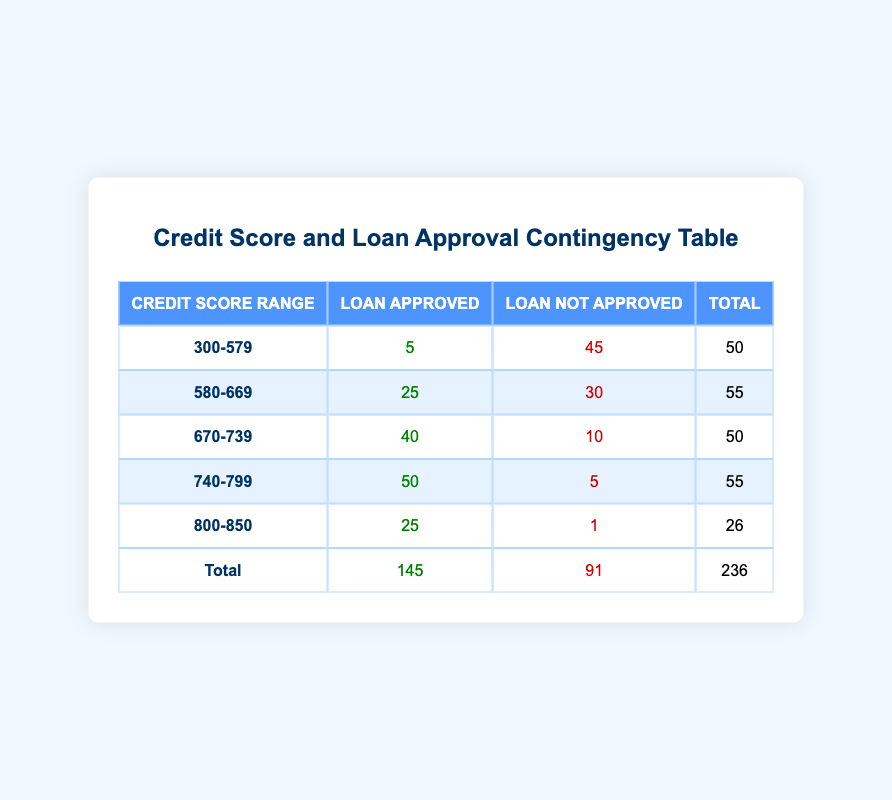What is the total number of loans approved for the credit score range 670-739? Looking at the table, the number of loans approved for the credit score range 670-739 is 40.
Answer: 40 What is the total number of loans not approved across all credit score ranges? Summing the values in the "Loan Not Approved" column gives: 45 + 30 + 10 + 5 + 1 = 91.
Answer: 91 Is it true that more loans were approved than not approved for the credit score range 740-799? In the 740-799 range, 50 loans were approved and 5 were not approved. Since 50 is greater than 5, this statement is true.
Answer: Yes What is the difference between the number of approved loans for the credit score ranges 580-669 and 670-739? The approved loans for 580-669 is 25 and for 670-739 is 40. The difference is 40 - 25 = 15.
Answer: 15 How many total loans were there for the credit score range 800-850? For the range 800-850, the total loans are calculated by adding the approved and not approved loans: 25 (approved) + 1 (not approved) = 26.
Answer: 26 What percentage of loans are approved for the credit score range 300-579? In the range 300-579, there are 5 approved loans out of a total of 50 (5 approved + 45 not approved), which is (5/50) * 100 = 10%.
Answer: 10% If we combine the ranges 580-669 and 740-799, what is the total number of loans approved? The approved loans for 580-669 is 25 and for 740-799 is 50. Summing these gives 25 + 50 = 75 approved loans total for both ranges.
Answer: 75 Is the number of loans not approved for the credit score range 800-850 less than those not approved for the range 300-579? For 800-850, there is 1 loan not approved, while for 300-579, there are 45 loans not approved. Since 1 is less than 45, the statement is true.
Answer: Yes What is the average number of approved loans across all credit score ranges? The total number of approved loans is 145. There are 5 credit score ranges, so the average is 145 / 5 = 29.
Answer: 29 